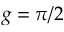<formula> <loc_0><loc_0><loc_500><loc_500>g = \pi / 2</formula> 